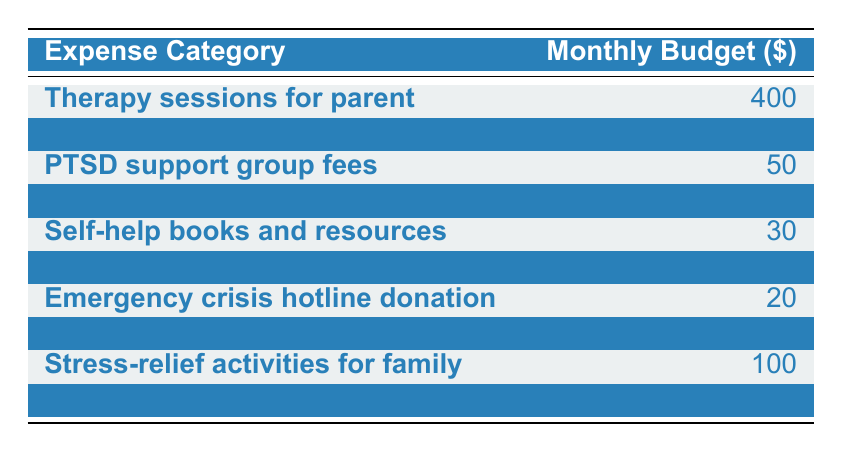What is the total monthly budget allocated for therapy sessions for the parent? The value for therapy sessions for the parent is directly found in the second row of the table, which states the amount is $400.
Answer: 400 How much is budgeted for family counseling? The budget for family counseling is located in the third row of the table, showing the amount is $250.
Answer: 250 What is the combined total for prescription medications and PTSD support group fees? First, find the budget amounts: prescription medications are $150 (row 4) and PTSD support group fees are $50 (row 3). Then add these two amounts: 150 + 50 = 200.
Answer: 200 Is the budget for meditation and relaxation apps higher than that for self-help books and resources? The budget for meditation and relaxation apps is $15 (row 6), and for self-help books and resources, it is $30 (row 5). Since 15 is not greater than 30, the answer is no.
Answer: No What is the average monthly budget for the stress-relief activities for the family and mental health education workshops? The stress-relief activities for the family are budgeted at $100 (row 9) and mental health education workshops at $60 (row 10). To find the average, sum these amounts (100 + 60 = 160) and divide by 2, resulting in 160 / 2 = 80.
Answer: 80 What is the total budget for all expense categories listed in the table? To find the total budget, add up all the individual budgets: 400 + 250 + 50 + 150 + 30 + 15 + 20 + 75 + 100 + 60 = 1050. Thus, the total budget is $1,050.
Answer: 1050 Are the total expenses for mental health education workshops and self-help books and resources less than $100? The budget for mental health education workshops is $60 (row 10) and for self-help books and resources is $30 (row 5). The combined total is 60 + 30 = 90, which is less than 100, making the answer yes.
Answer: Yes What category has the highest allocation in the monthly budget? By examining each row, therapy sessions for the parent has the highest budget of $400 (row 2). Thus, this is the category with the highest allocation.
Answer: Therapy sessions for parent What is the difference between the budgets allocated for transportation to appointments and the emergency crisis hotline donation? The budget for transportation to appointments is $75 (row 8), and for the emergency crisis hotline donation, it is $20 (row 7). The difference is calculated by subtracting the lower from the higher: 75 - 20 = 55.
Answer: 55 